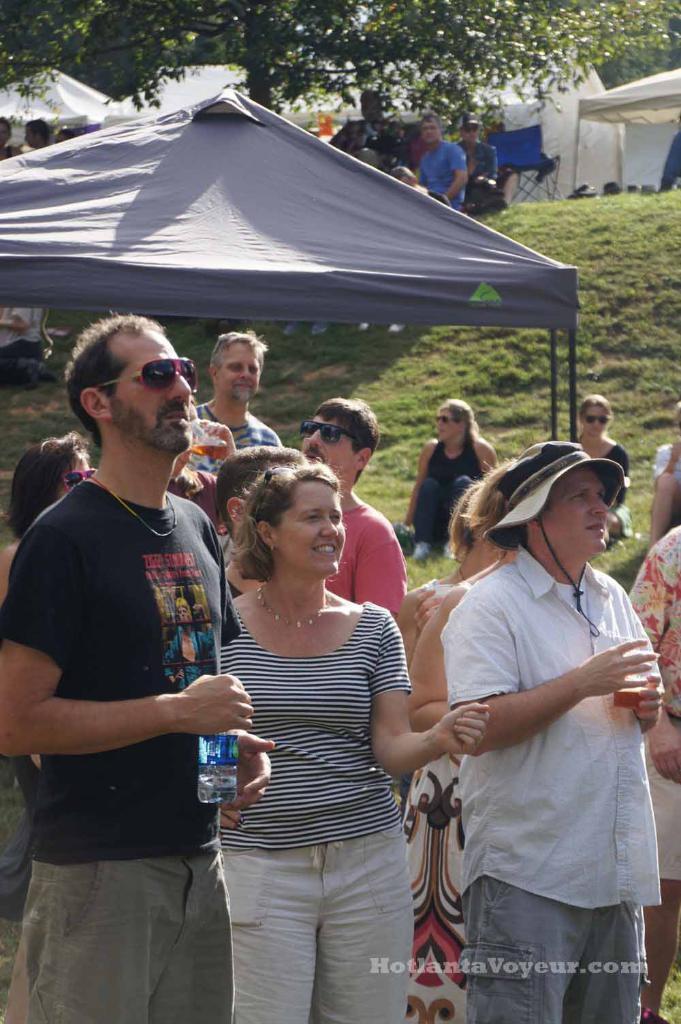Can you describe this image briefly? In this picture we can see some people standing here, there is a tent here, we can see grass here, in the background there are some tents, we can see a tree at the top of the picture. 